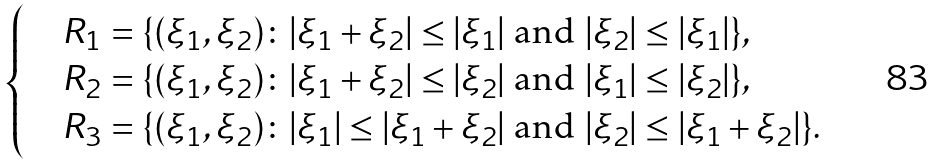Convert formula to latex. <formula><loc_0><loc_0><loc_500><loc_500>\begin{cases} & R _ { 1 } = \{ ( \xi _ { 1 } , \xi _ { 2 } ) \colon | \xi _ { 1 } + \xi _ { 2 } | \leq | \xi _ { 1 } | \text { and } | \xi _ { 2 } | \leq | \xi _ { 1 } | \} , \\ & R _ { 2 } = \{ ( \xi _ { 1 } , \xi _ { 2 } ) \colon | \xi _ { 1 } + \xi _ { 2 } | \leq | \xi _ { 2 } | \text { and } | \xi _ { 1 } | \leq | \xi _ { 2 } | \} , \\ & R _ { 3 } = \{ ( \xi _ { 1 } , \xi _ { 2 } ) \colon | \xi _ { 1 } | \leq | \xi _ { 1 } + \xi _ { 2 } | \text { and } | \xi _ { 2 } | \leq | \xi _ { 1 } + \xi _ { 2 } | \} . \end{cases}</formula> 